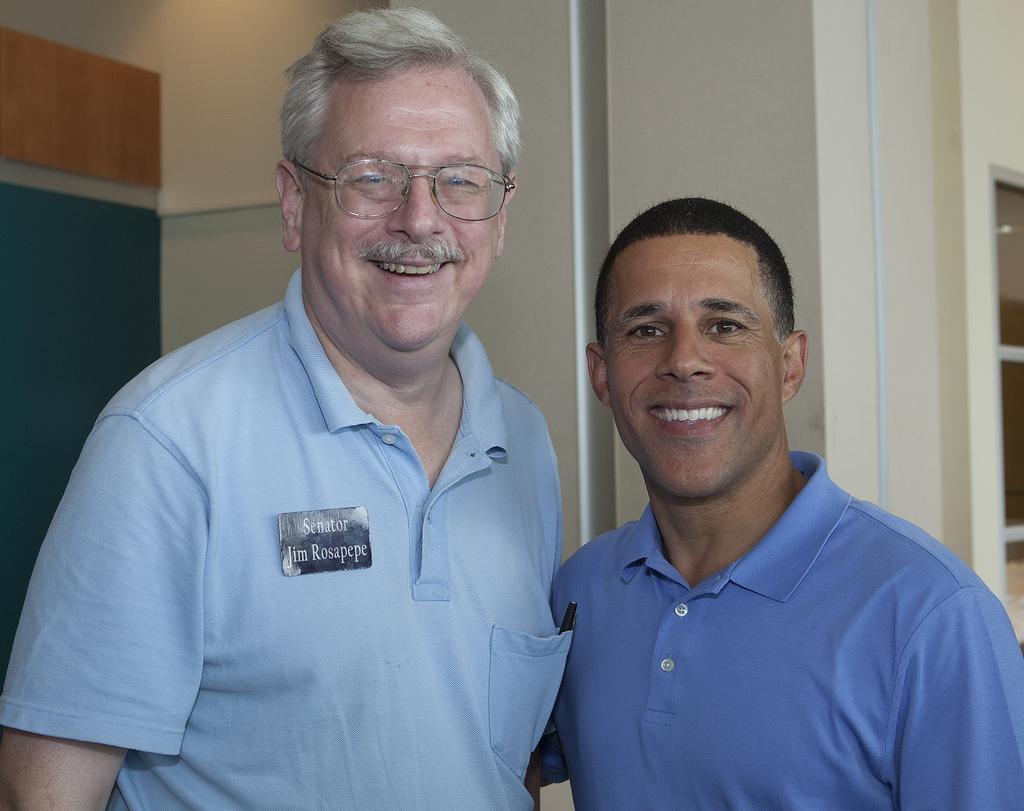Could you give a brief overview of what you see in this image? In this image I can see two persons and they are smiling and back side of them I can see the wall 